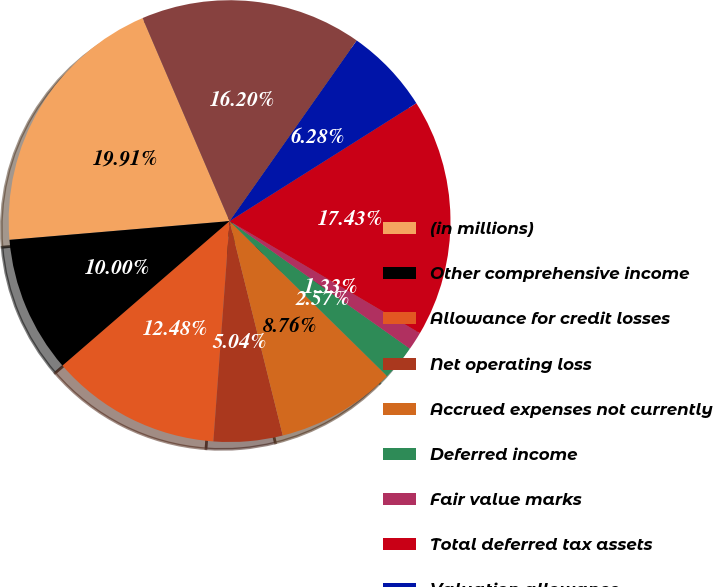<chart> <loc_0><loc_0><loc_500><loc_500><pie_chart><fcel>(in millions)<fcel>Other comprehensive income<fcel>Allowance for credit losses<fcel>Net operating loss<fcel>Accrued expenses not currently<fcel>Deferred income<fcel>Fair value marks<fcel>Total deferred tax assets<fcel>Valuation allowance<fcel>Deferred tax assets net of<nl><fcel>19.91%<fcel>10.0%<fcel>12.48%<fcel>5.04%<fcel>8.76%<fcel>2.57%<fcel>1.33%<fcel>17.43%<fcel>6.28%<fcel>16.2%<nl></chart> 